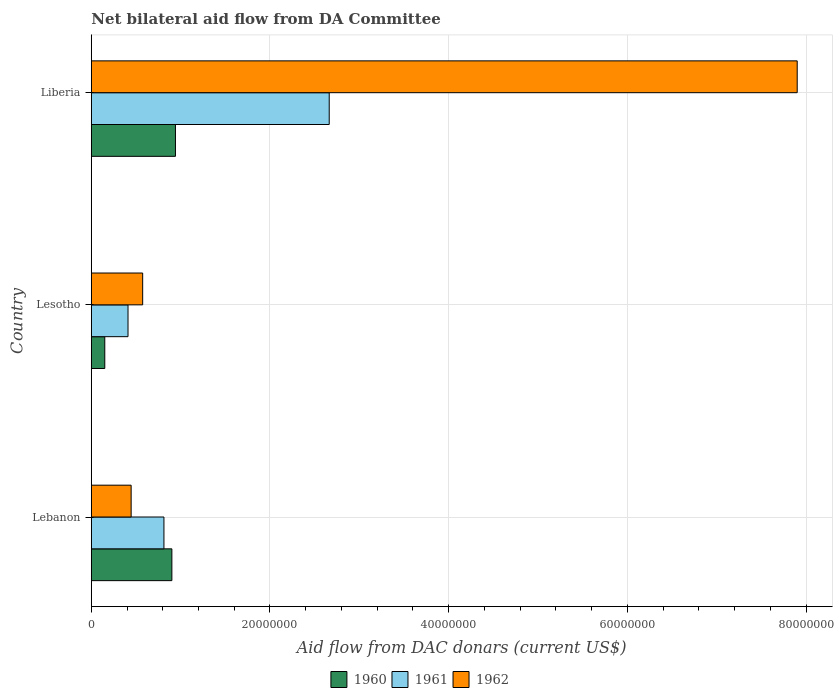Are the number of bars per tick equal to the number of legend labels?
Your response must be concise. Yes. How many bars are there on the 2nd tick from the top?
Keep it short and to the point. 3. How many bars are there on the 1st tick from the bottom?
Offer a very short reply. 3. What is the label of the 1st group of bars from the top?
Your answer should be very brief. Liberia. In how many cases, is the number of bars for a given country not equal to the number of legend labels?
Your answer should be compact. 0. What is the aid flow in in 1962 in Lesotho?
Your response must be concise. 5.75e+06. Across all countries, what is the maximum aid flow in in 1961?
Provide a succinct answer. 2.66e+07. Across all countries, what is the minimum aid flow in in 1961?
Your answer should be compact. 4.11e+06. In which country was the aid flow in in 1961 maximum?
Give a very brief answer. Liberia. In which country was the aid flow in in 1962 minimum?
Ensure brevity in your answer.  Lebanon. What is the total aid flow in in 1961 in the graph?
Offer a very short reply. 3.89e+07. What is the difference between the aid flow in in 1960 in Lebanon and that in Liberia?
Your answer should be very brief. -4.00e+05. What is the difference between the aid flow in in 1961 in Lesotho and the aid flow in in 1960 in Liberia?
Keep it short and to the point. -5.31e+06. What is the average aid flow in in 1961 per country?
Make the answer very short. 1.30e+07. What is the difference between the aid flow in in 1962 and aid flow in in 1960 in Lesotho?
Provide a succinct answer. 4.24e+06. What is the ratio of the aid flow in in 1960 in Lebanon to that in Lesotho?
Make the answer very short. 5.97. Is the aid flow in in 1960 in Lebanon less than that in Liberia?
Provide a short and direct response. Yes. Is the difference between the aid flow in in 1962 in Lebanon and Liberia greater than the difference between the aid flow in in 1960 in Lebanon and Liberia?
Ensure brevity in your answer.  No. What is the difference between the highest and the second highest aid flow in in 1962?
Provide a short and direct response. 7.33e+07. What is the difference between the highest and the lowest aid flow in in 1962?
Your answer should be very brief. 7.46e+07. In how many countries, is the aid flow in in 1960 greater than the average aid flow in in 1960 taken over all countries?
Offer a terse response. 2. Is it the case that in every country, the sum of the aid flow in in 1960 and aid flow in in 1961 is greater than the aid flow in in 1962?
Provide a short and direct response. No. Are all the bars in the graph horizontal?
Your answer should be compact. Yes. What is the difference between two consecutive major ticks on the X-axis?
Provide a succinct answer. 2.00e+07. Are the values on the major ticks of X-axis written in scientific E-notation?
Ensure brevity in your answer.  No. How are the legend labels stacked?
Your answer should be very brief. Horizontal. What is the title of the graph?
Keep it short and to the point. Net bilateral aid flow from DA Committee. Does "1989" appear as one of the legend labels in the graph?
Give a very brief answer. No. What is the label or title of the X-axis?
Give a very brief answer. Aid flow from DAC donars (current US$). What is the Aid flow from DAC donars (current US$) of 1960 in Lebanon?
Offer a terse response. 9.02e+06. What is the Aid flow from DAC donars (current US$) of 1961 in Lebanon?
Your answer should be compact. 8.13e+06. What is the Aid flow from DAC donars (current US$) of 1962 in Lebanon?
Make the answer very short. 4.46e+06. What is the Aid flow from DAC donars (current US$) in 1960 in Lesotho?
Make the answer very short. 1.51e+06. What is the Aid flow from DAC donars (current US$) in 1961 in Lesotho?
Keep it short and to the point. 4.11e+06. What is the Aid flow from DAC donars (current US$) of 1962 in Lesotho?
Provide a succinct answer. 5.75e+06. What is the Aid flow from DAC donars (current US$) in 1960 in Liberia?
Offer a very short reply. 9.42e+06. What is the Aid flow from DAC donars (current US$) in 1961 in Liberia?
Offer a very short reply. 2.66e+07. What is the Aid flow from DAC donars (current US$) in 1962 in Liberia?
Provide a short and direct response. 7.90e+07. Across all countries, what is the maximum Aid flow from DAC donars (current US$) of 1960?
Make the answer very short. 9.42e+06. Across all countries, what is the maximum Aid flow from DAC donars (current US$) of 1961?
Keep it short and to the point. 2.66e+07. Across all countries, what is the maximum Aid flow from DAC donars (current US$) of 1962?
Your response must be concise. 7.90e+07. Across all countries, what is the minimum Aid flow from DAC donars (current US$) in 1960?
Keep it short and to the point. 1.51e+06. Across all countries, what is the minimum Aid flow from DAC donars (current US$) of 1961?
Give a very brief answer. 4.11e+06. Across all countries, what is the minimum Aid flow from DAC donars (current US$) in 1962?
Offer a terse response. 4.46e+06. What is the total Aid flow from DAC donars (current US$) of 1960 in the graph?
Your answer should be compact. 2.00e+07. What is the total Aid flow from DAC donars (current US$) of 1961 in the graph?
Provide a short and direct response. 3.89e+07. What is the total Aid flow from DAC donars (current US$) of 1962 in the graph?
Make the answer very short. 8.92e+07. What is the difference between the Aid flow from DAC donars (current US$) of 1960 in Lebanon and that in Lesotho?
Keep it short and to the point. 7.51e+06. What is the difference between the Aid flow from DAC donars (current US$) of 1961 in Lebanon and that in Lesotho?
Your response must be concise. 4.02e+06. What is the difference between the Aid flow from DAC donars (current US$) of 1962 in Lebanon and that in Lesotho?
Make the answer very short. -1.29e+06. What is the difference between the Aid flow from DAC donars (current US$) of 1960 in Lebanon and that in Liberia?
Offer a terse response. -4.00e+05. What is the difference between the Aid flow from DAC donars (current US$) of 1961 in Lebanon and that in Liberia?
Make the answer very short. -1.85e+07. What is the difference between the Aid flow from DAC donars (current US$) in 1962 in Lebanon and that in Liberia?
Make the answer very short. -7.46e+07. What is the difference between the Aid flow from DAC donars (current US$) in 1960 in Lesotho and that in Liberia?
Your response must be concise. -7.91e+06. What is the difference between the Aid flow from DAC donars (current US$) in 1961 in Lesotho and that in Liberia?
Provide a succinct answer. -2.25e+07. What is the difference between the Aid flow from DAC donars (current US$) in 1962 in Lesotho and that in Liberia?
Provide a succinct answer. -7.33e+07. What is the difference between the Aid flow from DAC donars (current US$) of 1960 in Lebanon and the Aid flow from DAC donars (current US$) of 1961 in Lesotho?
Your response must be concise. 4.91e+06. What is the difference between the Aid flow from DAC donars (current US$) in 1960 in Lebanon and the Aid flow from DAC donars (current US$) in 1962 in Lesotho?
Your response must be concise. 3.27e+06. What is the difference between the Aid flow from DAC donars (current US$) in 1961 in Lebanon and the Aid flow from DAC donars (current US$) in 1962 in Lesotho?
Offer a terse response. 2.38e+06. What is the difference between the Aid flow from DAC donars (current US$) of 1960 in Lebanon and the Aid flow from DAC donars (current US$) of 1961 in Liberia?
Provide a short and direct response. -1.76e+07. What is the difference between the Aid flow from DAC donars (current US$) in 1960 in Lebanon and the Aid flow from DAC donars (current US$) in 1962 in Liberia?
Provide a succinct answer. -7.00e+07. What is the difference between the Aid flow from DAC donars (current US$) in 1961 in Lebanon and the Aid flow from DAC donars (current US$) in 1962 in Liberia?
Offer a terse response. -7.09e+07. What is the difference between the Aid flow from DAC donars (current US$) in 1960 in Lesotho and the Aid flow from DAC donars (current US$) in 1961 in Liberia?
Provide a succinct answer. -2.51e+07. What is the difference between the Aid flow from DAC donars (current US$) in 1960 in Lesotho and the Aid flow from DAC donars (current US$) in 1962 in Liberia?
Give a very brief answer. -7.75e+07. What is the difference between the Aid flow from DAC donars (current US$) of 1961 in Lesotho and the Aid flow from DAC donars (current US$) of 1962 in Liberia?
Your answer should be compact. -7.49e+07. What is the average Aid flow from DAC donars (current US$) in 1960 per country?
Keep it short and to the point. 6.65e+06. What is the average Aid flow from DAC donars (current US$) in 1961 per country?
Make the answer very short. 1.30e+07. What is the average Aid flow from DAC donars (current US$) in 1962 per country?
Your answer should be compact. 2.97e+07. What is the difference between the Aid flow from DAC donars (current US$) in 1960 and Aid flow from DAC donars (current US$) in 1961 in Lebanon?
Ensure brevity in your answer.  8.90e+05. What is the difference between the Aid flow from DAC donars (current US$) in 1960 and Aid flow from DAC donars (current US$) in 1962 in Lebanon?
Make the answer very short. 4.56e+06. What is the difference between the Aid flow from DAC donars (current US$) in 1961 and Aid flow from DAC donars (current US$) in 1962 in Lebanon?
Make the answer very short. 3.67e+06. What is the difference between the Aid flow from DAC donars (current US$) in 1960 and Aid flow from DAC donars (current US$) in 1961 in Lesotho?
Your answer should be compact. -2.60e+06. What is the difference between the Aid flow from DAC donars (current US$) of 1960 and Aid flow from DAC donars (current US$) of 1962 in Lesotho?
Your answer should be compact. -4.24e+06. What is the difference between the Aid flow from DAC donars (current US$) in 1961 and Aid flow from DAC donars (current US$) in 1962 in Lesotho?
Ensure brevity in your answer.  -1.64e+06. What is the difference between the Aid flow from DAC donars (current US$) of 1960 and Aid flow from DAC donars (current US$) of 1961 in Liberia?
Ensure brevity in your answer.  -1.72e+07. What is the difference between the Aid flow from DAC donars (current US$) in 1960 and Aid flow from DAC donars (current US$) in 1962 in Liberia?
Your answer should be very brief. -6.96e+07. What is the difference between the Aid flow from DAC donars (current US$) of 1961 and Aid flow from DAC donars (current US$) of 1962 in Liberia?
Provide a succinct answer. -5.24e+07. What is the ratio of the Aid flow from DAC donars (current US$) of 1960 in Lebanon to that in Lesotho?
Provide a succinct answer. 5.97. What is the ratio of the Aid flow from DAC donars (current US$) of 1961 in Lebanon to that in Lesotho?
Give a very brief answer. 1.98. What is the ratio of the Aid flow from DAC donars (current US$) of 1962 in Lebanon to that in Lesotho?
Your response must be concise. 0.78. What is the ratio of the Aid flow from DAC donars (current US$) in 1960 in Lebanon to that in Liberia?
Your answer should be compact. 0.96. What is the ratio of the Aid flow from DAC donars (current US$) of 1961 in Lebanon to that in Liberia?
Offer a terse response. 0.31. What is the ratio of the Aid flow from DAC donars (current US$) of 1962 in Lebanon to that in Liberia?
Keep it short and to the point. 0.06. What is the ratio of the Aid flow from DAC donars (current US$) of 1960 in Lesotho to that in Liberia?
Your answer should be very brief. 0.16. What is the ratio of the Aid flow from DAC donars (current US$) of 1961 in Lesotho to that in Liberia?
Your response must be concise. 0.15. What is the ratio of the Aid flow from DAC donars (current US$) of 1962 in Lesotho to that in Liberia?
Give a very brief answer. 0.07. What is the difference between the highest and the second highest Aid flow from DAC donars (current US$) of 1960?
Provide a short and direct response. 4.00e+05. What is the difference between the highest and the second highest Aid flow from DAC donars (current US$) of 1961?
Keep it short and to the point. 1.85e+07. What is the difference between the highest and the second highest Aid flow from DAC donars (current US$) in 1962?
Your answer should be very brief. 7.33e+07. What is the difference between the highest and the lowest Aid flow from DAC donars (current US$) in 1960?
Your answer should be compact. 7.91e+06. What is the difference between the highest and the lowest Aid flow from DAC donars (current US$) in 1961?
Your response must be concise. 2.25e+07. What is the difference between the highest and the lowest Aid flow from DAC donars (current US$) in 1962?
Your answer should be very brief. 7.46e+07. 